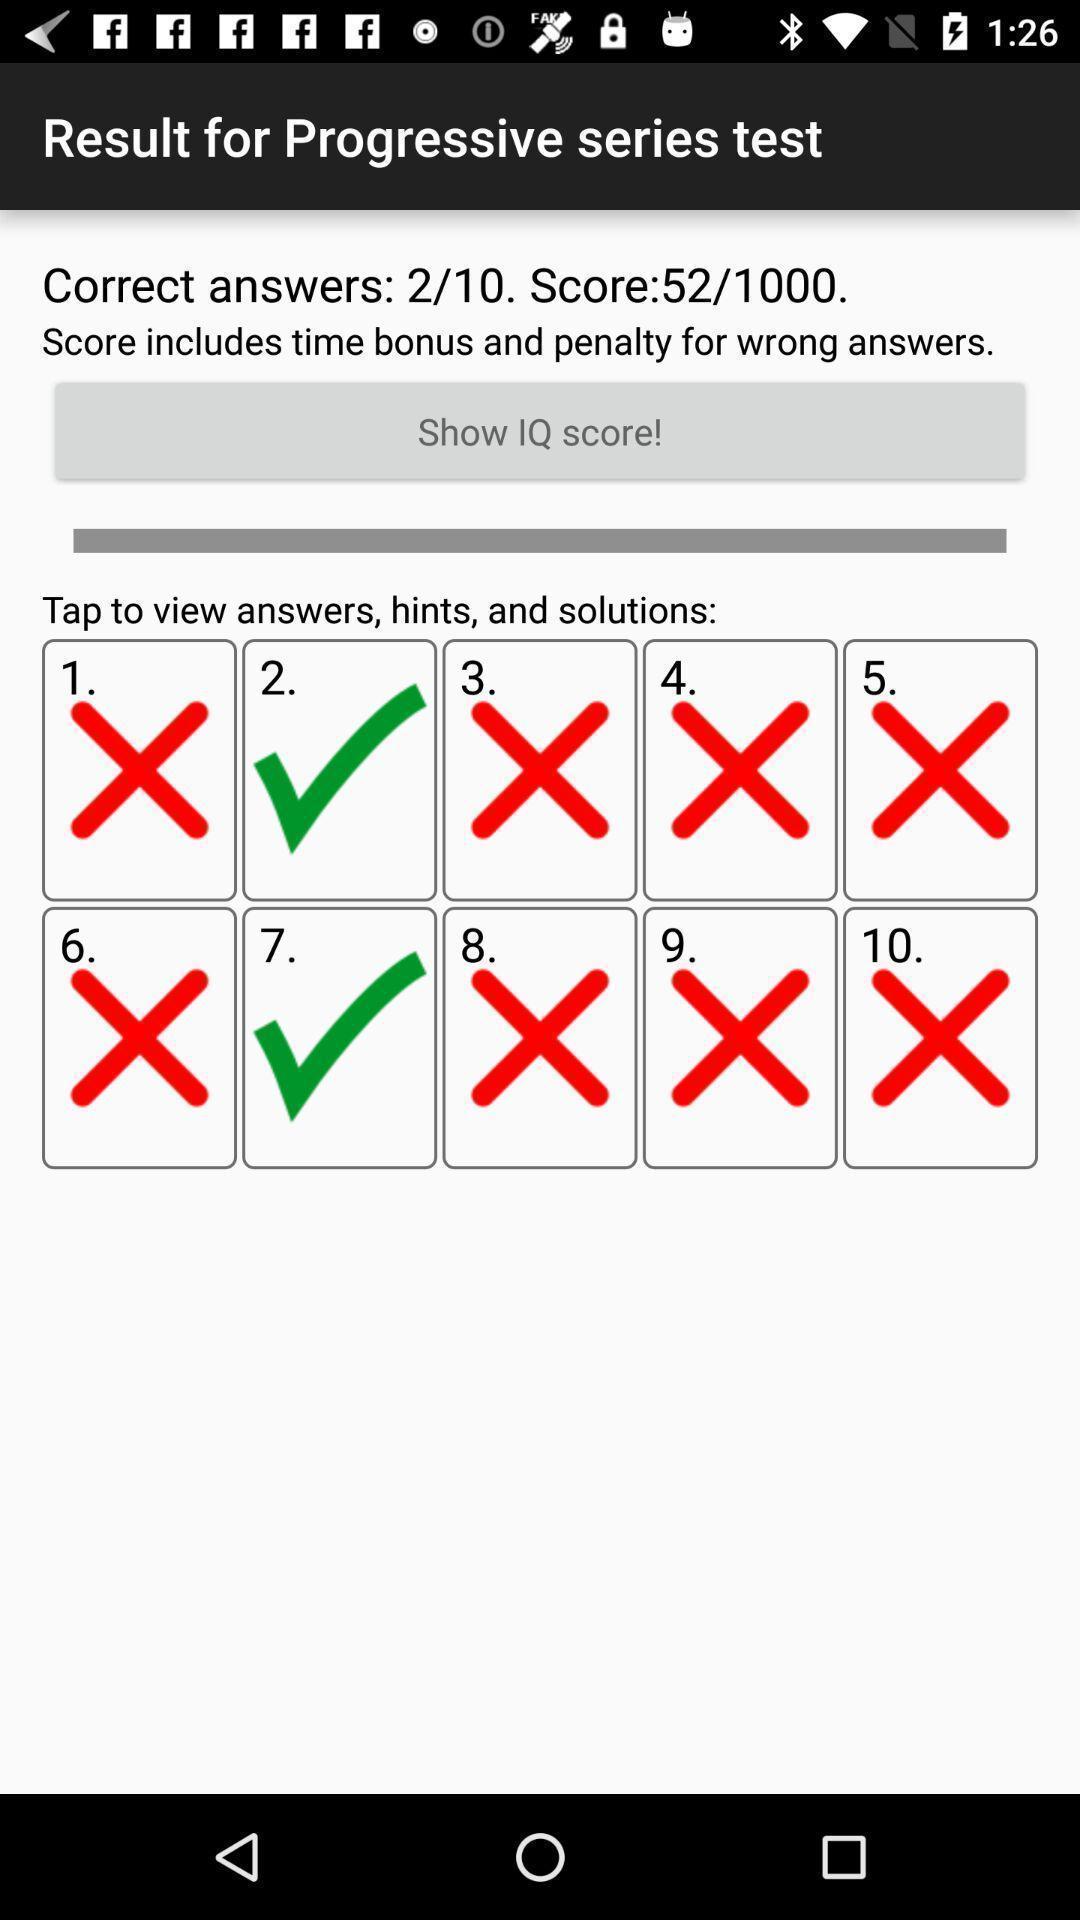Describe the visual elements of this screenshot. Window displaying a test app. 